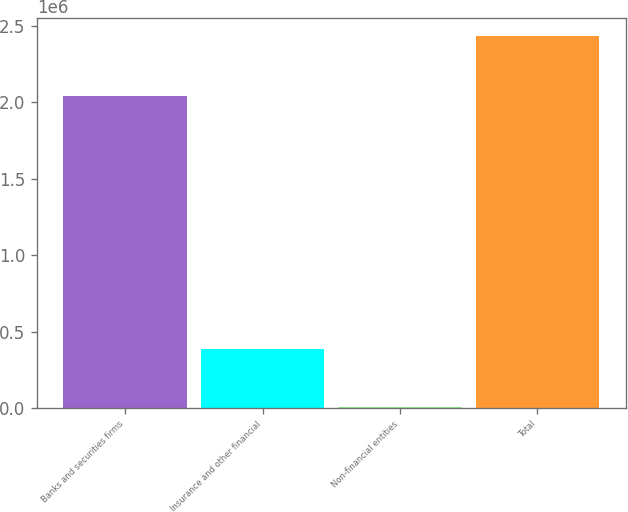Convert chart to OTSL. <chart><loc_0><loc_0><loc_500><loc_500><bar_chart><fcel>Banks and securities firms<fcel>Insurance and other financial<fcel>Non-financial entities<fcel>Total<nl><fcel>2.03956e+06<fcel>386720<fcel>6129<fcel>2.4324e+06<nl></chart> 